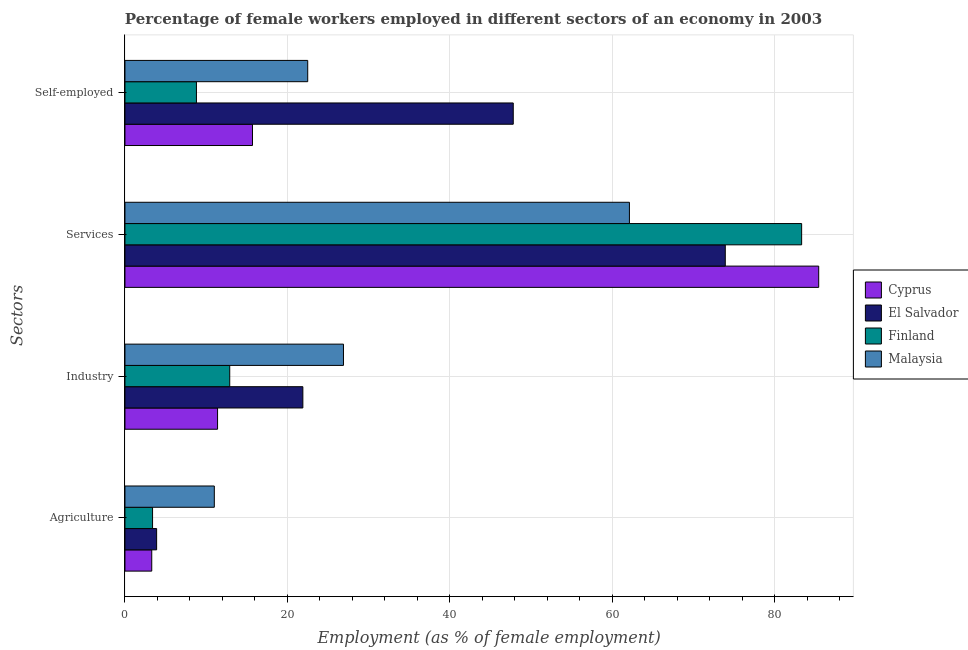How many groups of bars are there?
Give a very brief answer. 4. Are the number of bars on each tick of the Y-axis equal?
Provide a short and direct response. Yes. What is the label of the 2nd group of bars from the top?
Keep it short and to the point. Services. What is the percentage of female workers in services in Cyprus?
Your answer should be very brief. 85.4. Across all countries, what is the maximum percentage of self employed female workers?
Make the answer very short. 47.8. Across all countries, what is the minimum percentage of self employed female workers?
Provide a short and direct response. 8.8. In which country was the percentage of female workers in agriculture maximum?
Your response must be concise. Malaysia. In which country was the percentage of female workers in agriculture minimum?
Ensure brevity in your answer.  Cyprus. What is the total percentage of self employed female workers in the graph?
Give a very brief answer. 94.8. What is the difference between the percentage of female workers in services in Finland and that in Malaysia?
Provide a short and direct response. 21.2. What is the difference between the percentage of self employed female workers in Cyprus and the percentage of female workers in services in Finland?
Your answer should be compact. -67.6. What is the average percentage of female workers in industry per country?
Provide a short and direct response. 18.27. What is the difference between the percentage of self employed female workers and percentage of female workers in industry in Cyprus?
Offer a very short reply. 4.3. In how many countries, is the percentage of female workers in services greater than 68 %?
Make the answer very short. 3. What is the ratio of the percentage of female workers in industry in Malaysia to that in Cyprus?
Offer a terse response. 2.36. Is the percentage of female workers in agriculture in Malaysia less than that in Cyprus?
Ensure brevity in your answer.  No. What is the difference between the highest and the second highest percentage of female workers in agriculture?
Ensure brevity in your answer.  7.1. What is the difference between the highest and the lowest percentage of self employed female workers?
Your response must be concise. 39. What does the 1st bar from the top in Services represents?
Your answer should be compact. Malaysia. What does the 1st bar from the bottom in Agriculture represents?
Make the answer very short. Cyprus. Is it the case that in every country, the sum of the percentage of female workers in agriculture and percentage of female workers in industry is greater than the percentage of female workers in services?
Provide a succinct answer. No. What is the difference between two consecutive major ticks on the X-axis?
Offer a terse response. 20. Are the values on the major ticks of X-axis written in scientific E-notation?
Give a very brief answer. No. Does the graph contain any zero values?
Provide a succinct answer. No. Does the graph contain grids?
Keep it short and to the point. Yes. Where does the legend appear in the graph?
Make the answer very short. Center right. How are the legend labels stacked?
Ensure brevity in your answer.  Vertical. What is the title of the graph?
Your answer should be compact. Percentage of female workers employed in different sectors of an economy in 2003. Does "Romania" appear as one of the legend labels in the graph?
Provide a succinct answer. No. What is the label or title of the X-axis?
Provide a succinct answer. Employment (as % of female employment). What is the label or title of the Y-axis?
Offer a very short reply. Sectors. What is the Employment (as % of female employment) of Cyprus in Agriculture?
Keep it short and to the point. 3.3. What is the Employment (as % of female employment) in El Salvador in Agriculture?
Provide a short and direct response. 3.9. What is the Employment (as % of female employment) in Finland in Agriculture?
Your answer should be very brief. 3.4. What is the Employment (as % of female employment) in Malaysia in Agriculture?
Ensure brevity in your answer.  11. What is the Employment (as % of female employment) of Cyprus in Industry?
Keep it short and to the point. 11.4. What is the Employment (as % of female employment) in El Salvador in Industry?
Your answer should be compact. 21.9. What is the Employment (as % of female employment) of Finland in Industry?
Your answer should be compact. 12.9. What is the Employment (as % of female employment) of Malaysia in Industry?
Provide a short and direct response. 26.9. What is the Employment (as % of female employment) of Cyprus in Services?
Ensure brevity in your answer.  85.4. What is the Employment (as % of female employment) in El Salvador in Services?
Your answer should be very brief. 73.9. What is the Employment (as % of female employment) in Finland in Services?
Provide a succinct answer. 83.3. What is the Employment (as % of female employment) in Malaysia in Services?
Provide a succinct answer. 62.1. What is the Employment (as % of female employment) in Cyprus in Self-employed?
Offer a very short reply. 15.7. What is the Employment (as % of female employment) of El Salvador in Self-employed?
Give a very brief answer. 47.8. What is the Employment (as % of female employment) in Finland in Self-employed?
Provide a short and direct response. 8.8. What is the Employment (as % of female employment) of Malaysia in Self-employed?
Make the answer very short. 22.5. Across all Sectors, what is the maximum Employment (as % of female employment) in Cyprus?
Offer a very short reply. 85.4. Across all Sectors, what is the maximum Employment (as % of female employment) in El Salvador?
Offer a terse response. 73.9. Across all Sectors, what is the maximum Employment (as % of female employment) in Finland?
Offer a very short reply. 83.3. Across all Sectors, what is the maximum Employment (as % of female employment) of Malaysia?
Offer a very short reply. 62.1. Across all Sectors, what is the minimum Employment (as % of female employment) of Cyprus?
Provide a succinct answer. 3.3. Across all Sectors, what is the minimum Employment (as % of female employment) of El Salvador?
Your answer should be compact. 3.9. Across all Sectors, what is the minimum Employment (as % of female employment) in Finland?
Provide a succinct answer. 3.4. What is the total Employment (as % of female employment) of Cyprus in the graph?
Provide a succinct answer. 115.8. What is the total Employment (as % of female employment) in El Salvador in the graph?
Keep it short and to the point. 147.5. What is the total Employment (as % of female employment) in Finland in the graph?
Your answer should be compact. 108.4. What is the total Employment (as % of female employment) in Malaysia in the graph?
Make the answer very short. 122.5. What is the difference between the Employment (as % of female employment) in Cyprus in Agriculture and that in Industry?
Your response must be concise. -8.1. What is the difference between the Employment (as % of female employment) in El Salvador in Agriculture and that in Industry?
Your answer should be compact. -18. What is the difference between the Employment (as % of female employment) in Finland in Agriculture and that in Industry?
Make the answer very short. -9.5. What is the difference between the Employment (as % of female employment) in Malaysia in Agriculture and that in Industry?
Ensure brevity in your answer.  -15.9. What is the difference between the Employment (as % of female employment) of Cyprus in Agriculture and that in Services?
Your response must be concise. -82.1. What is the difference between the Employment (as % of female employment) in El Salvador in Agriculture and that in Services?
Make the answer very short. -70. What is the difference between the Employment (as % of female employment) of Finland in Agriculture and that in Services?
Offer a terse response. -79.9. What is the difference between the Employment (as % of female employment) in Malaysia in Agriculture and that in Services?
Offer a terse response. -51.1. What is the difference between the Employment (as % of female employment) in Cyprus in Agriculture and that in Self-employed?
Provide a succinct answer. -12.4. What is the difference between the Employment (as % of female employment) in El Salvador in Agriculture and that in Self-employed?
Offer a very short reply. -43.9. What is the difference between the Employment (as % of female employment) of Malaysia in Agriculture and that in Self-employed?
Ensure brevity in your answer.  -11.5. What is the difference between the Employment (as % of female employment) in Cyprus in Industry and that in Services?
Your response must be concise. -74. What is the difference between the Employment (as % of female employment) of El Salvador in Industry and that in Services?
Offer a very short reply. -52. What is the difference between the Employment (as % of female employment) of Finland in Industry and that in Services?
Keep it short and to the point. -70.4. What is the difference between the Employment (as % of female employment) in Malaysia in Industry and that in Services?
Provide a succinct answer. -35.2. What is the difference between the Employment (as % of female employment) in Cyprus in Industry and that in Self-employed?
Give a very brief answer. -4.3. What is the difference between the Employment (as % of female employment) in El Salvador in Industry and that in Self-employed?
Give a very brief answer. -25.9. What is the difference between the Employment (as % of female employment) of Malaysia in Industry and that in Self-employed?
Give a very brief answer. 4.4. What is the difference between the Employment (as % of female employment) of Cyprus in Services and that in Self-employed?
Your answer should be very brief. 69.7. What is the difference between the Employment (as % of female employment) of El Salvador in Services and that in Self-employed?
Keep it short and to the point. 26.1. What is the difference between the Employment (as % of female employment) in Finland in Services and that in Self-employed?
Offer a very short reply. 74.5. What is the difference between the Employment (as % of female employment) in Malaysia in Services and that in Self-employed?
Make the answer very short. 39.6. What is the difference between the Employment (as % of female employment) in Cyprus in Agriculture and the Employment (as % of female employment) in El Salvador in Industry?
Keep it short and to the point. -18.6. What is the difference between the Employment (as % of female employment) in Cyprus in Agriculture and the Employment (as % of female employment) in Malaysia in Industry?
Your response must be concise. -23.6. What is the difference between the Employment (as % of female employment) in Finland in Agriculture and the Employment (as % of female employment) in Malaysia in Industry?
Offer a very short reply. -23.5. What is the difference between the Employment (as % of female employment) of Cyprus in Agriculture and the Employment (as % of female employment) of El Salvador in Services?
Give a very brief answer. -70.6. What is the difference between the Employment (as % of female employment) of Cyprus in Agriculture and the Employment (as % of female employment) of Finland in Services?
Make the answer very short. -80. What is the difference between the Employment (as % of female employment) in Cyprus in Agriculture and the Employment (as % of female employment) in Malaysia in Services?
Give a very brief answer. -58.8. What is the difference between the Employment (as % of female employment) of El Salvador in Agriculture and the Employment (as % of female employment) of Finland in Services?
Your answer should be compact. -79.4. What is the difference between the Employment (as % of female employment) of El Salvador in Agriculture and the Employment (as % of female employment) of Malaysia in Services?
Give a very brief answer. -58.2. What is the difference between the Employment (as % of female employment) of Finland in Agriculture and the Employment (as % of female employment) of Malaysia in Services?
Give a very brief answer. -58.7. What is the difference between the Employment (as % of female employment) of Cyprus in Agriculture and the Employment (as % of female employment) of El Salvador in Self-employed?
Ensure brevity in your answer.  -44.5. What is the difference between the Employment (as % of female employment) in Cyprus in Agriculture and the Employment (as % of female employment) in Finland in Self-employed?
Your answer should be compact. -5.5. What is the difference between the Employment (as % of female employment) in Cyprus in Agriculture and the Employment (as % of female employment) in Malaysia in Self-employed?
Your response must be concise. -19.2. What is the difference between the Employment (as % of female employment) of El Salvador in Agriculture and the Employment (as % of female employment) of Malaysia in Self-employed?
Make the answer very short. -18.6. What is the difference between the Employment (as % of female employment) of Finland in Agriculture and the Employment (as % of female employment) of Malaysia in Self-employed?
Your answer should be very brief. -19.1. What is the difference between the Employment (as % of female employment) of Cyprus in Industry and the Employment (as % of female employment) of El Salvador in Services?
Keep it short and to the point. -62.5. What is the difference between the Employment (as % of female employment) in Cyprus in Industry and the Employment (as % of female employment) in Finland in Services?
Give a very brief answer. -71.9. What is the difference between the Employment (as % of female employment) in Cyprus in Industry and the Employment (as % of female employment) in Malaysia in Services?
Your answer should be very brief. -50.7. What is the difference between the Employment (as % of female employment) in El Salvador in Industry and the Employment (as % of female employment) in Finland in Services?
Offer a terse response. -61.4. What is the difference between the Employment (as % of female employment) in El Salvador in Industry and the Employment (as % of female employment) in Malaysia in Services?
Make the answer very short. -40.2. What is the difference between the Employment (as % of female employment) in Finland in Industry and the Employment (as % of female employment) in Malaysia in Services?
Ensure brevity in your answer.  -49.2. What is the difference between the Employment (as % of female employment) of Cyprus in Industry and the Employment (as % of female employment) of El Salvador in Self-employed?
Your answer should be very brief. -36.4. What is the difference between the Employment (as % of female employment) of El Salvador in Industry and the Employment (as % of female employment) of Finland in Self-employed?
Provide a succinct answer. 13.1. What is the difference between the Employment (as % of female employment) in Cyprus in Services and the Employment (as % of female employment) in El Salvador in Self-employed?
Give a very brief answer. 37.6. What is the difference between the Employment (as % of female employment) in Cyprus in Services and the Employment (as % of female employment) in Finland in Self-employed?
Offer a very short reply. 76.6. What is the difference between the Employment (as % of female employment) of Cyprus in Services and the Employment (as % of female employment) of Malaysia in Self-employed?
Your answer should be compact. 62.9. What is the difference between the Employment (as % of female employment) of El Salvador in Services and the Employment (as % of female employment) of Finland in Self-employed?
Offer a very short reply. 65.1. What is the difference between the Employment (as % of female employment) of El Salvador in Services and the Employment (as % of female employment) of Malaysia in Self-employed?
Offer a terse response. 51.4. What is the difference between the Employment (as % of female employment) in Finland in Services and the Employment (as % of female employment) in Malaysia in Self-employed?
Offer a terse response. 60.8. What is the average Employment (as % of female employment) in Cyprus per Sectors?
Provide a short and direct response. 28.95. What is the average Employment (as % of female employment) in El Salvador per Sectors?
Give a very brief answer. 36.88. What is the average Employment (as % of female employment) of Finland per Sectors?
Give a very brief answer. 27.1. What is the average Employment (as % of female employment) in Malaysia per Sectors?
Your answer should be very brief. 30.62. What is the difference between the Employment (as % of female employment) of El Salvador and Employment (as % of female employment) of Finland in Agriculture?
Your response must be concise. 0.5. What is the difference between the Employment (as % of female employment) of El Salvador and Employment (as % of female employment) of Malaysia in Agriculture?
Provide a short and direct response. -7.1. What is the difference between the Employment (as % of female employment) in Finland and Employment (as % of female employment) in Malaysia in Agriculture?
Your answer should be very brief. -7.6. What is the difference between the Employment (as % of female employment) in Cyprus and Employment (as % of female employment) in Finland in Industry?
Give a very brief answer. -1.5. What is the difference between the Employment (as % of female employment) of Cyprus and Employment (as % of female employment) of Malaysia in Industry?
Offer a very short reply. -15.5. What is the difference between the Employment (as % of female employment) of El Salvador and Employment (as % of female employment) of Malaysia in Industry?
Your answer should be compact. -5. What is the difference between the Employment (as % of female employment) in Finland and Employment (as % of female employment) in Malaysia in Industry?
Offer a terse response. -14. What is the difference between the Employment (as % of female employment) in Cyprus and Employment (as % of female employment) in Finland in Services?
Ensure brevity in your answer.  2.1. What is the difference between the Employment (as % of female employment) of Cyprus and Employment (as % of female employment) of Malaysia in Services?
Give a very brief answer. 23.3. What is the difference between the Employment (as % of female employment) in El Salvador and Employment (as % of female employment) in Finland in Services?
Give a very brief answer. -9.4. What is the difference between the Employment (as % of female employment) in El Salvador and Employment (as % of female employment) in Malaysia in Services?
Your answer should be compact. 11.8. What is the difference between the Employment (as % of female employment) in Finland and Employment (as % of female employment) in Malaysia in Services?
Keep it short and to the point. 21.2. What is the difference between the Employment (as % of female employment) of Cyprus and Employment (as % of female employment) of El Salvador in Self-employed?
Provide a succinct answer. -32.1. What is the difference between the Employment (as % of female employment) in Cyprus and Employment (as % of female employment) in Finland in Self-employed?
Your answer should be very brief. 6.9. What is the difference between the Employment (as % of female employment) of El Salvador and Employment (as % of female employment) of Malaysia in Self-employed?
Give a very brief answer. 25.3. What is the difference between the Employment (as % of female employment) in Finland and Employment (as % of female employment) in Malaysia in Self-employed?
Keep it short and to the point. -13.7. What is the ratio of the Employment (as % of female employment) of Cyprus in Agriculture to that in Industry?
Offer a very short reply. 0.29. What is the ratio of the Employment (as % of female employment) in El Salvador in Agriculture to that in Industry?
Make the answer very short. 0.18. What is the ratio of the Employment (as % of female employment) in Finland in Agriculture to that in Industry?
Offer a terse response. 0.26. What is the ratio of the Employment (as % of female employment) in Malaysia in Agriculture to that in Industry?
Ensure brevity in your answer.  0.41. What is the ratio of the Employment (as % of female employment) of Cyprus in Agriculture to that in Services?
Your response must be concise. 0.04. What is the ratio of the Employment (as % of female employment) in El Salvador in Agriculture to that in Services?
Your answer should be very brief. 0.05. What is the ratio of the Employment (as % of female employment) of Finland in Agriculture to that in Services?
Make the answer very short. 0.04. What is the ratio of the Employment (as % of female employment) in Malaysia in Agriculture to that in Services?
Offer a terse response. 0.18. What is the ratio of the Employment (as % of female employment) in Cyprus in Agriculture to that in Self-employed?
Provide a short and direct response. 0.21. What is the ratio of the Employment (as % of female employment) of El Salvador in Agriculture to that in Self-employed?
Your answer should be very brief. 0.08. What is the ratio of the Employment (as % of female employment) of Finland in Agriculture to that in Self-employed?
Offer a terse response. 0.39. What is the ratio of the Employment (as % of female employment) of Malaysia in Agriculture to that in Self-employed?
Ensure brevity in your answer.  0.49. What is the ratio of the Employment (as % of female employment) of Cyprus in Industry to that in Services?
Your answer should be very brief. 0.13. What is the ratio of the Employment (as % of female employment) in El Salvador in Industry to that in Services?
Keep it short and to the point. 0.3. What is the ratio of the Employment (as % of female employment) of Finland in Industry to that in Services?
Provide a short and direct response. 0.15. What is the ratio of the Employment (as % of female employment) in Malaysia in Industry to that in Services?
Provide a succinct answer. 0.43. What is the ratio of the Employment (as % of female employment) of Cyprus in Industry to that in Self-employed?
Keep it short and to the point. 0.73. What is the ratio of the Employment (as % of female employment) in El Salvador in Industry to that in Self-employed?
Make the answer very short. 0.46. What is the ratio of the Employment (as % of female employment) of Finland in Industry to that in Self-employed?
Offer a very short reply. 1.47. What is the ratio of the Employment (as % of female employment) of Malaysia in Industry to that in Self-employed?
Ensure brevity in your answer.  1.2. What is the ratio of the Employment (as % of female employment) of Cyprus in Services to that in Self-employed?
Your answer should be very brief. 5.44. What is the ratio of the Employment (as % of female employment) in El Salvador in Services to that in Self-employed?
Your answer should be compact. 1.55. What is the ratio of the Employment (as % of female employment) in Finland in Services to that in Self-employed?
Offer a very short reply. 9.47. What is the ratio of the Employment (as % of female employment) in Malaysia in Services to that in Self-employed?
Make the answer very short. 2.76. What is the difference between the highest and the second highest Employment (as % of female employment) of Cyprus?
Keep it short and to the point. 69.7. What is the difference between the highest and the second highest Employment (as % of female employment) in El Salvador?
Your answer should be very brief. 26.1. What is the difference between the highest and the second highest Employment (as % of female employment) in Finland?
Offer a terse response. 70.4. What is the difference between the highest and the second highest Employment (as % of female employment) in Malaysia?
Offer a terse response. 35.2. What is the difference between the highest and the lowest Employment (as % of female employment) of Cyprus?
Provide a succinct answer. 82.1. What is the difference between the highest and the lowest Employment (as % of female employment) in Finland?
Offer a very short reply. 79.9. What is the difference between the highest and the lowest Employment (as % of female employment) of Malaysia?
Give a very brief answer. 51.1. 